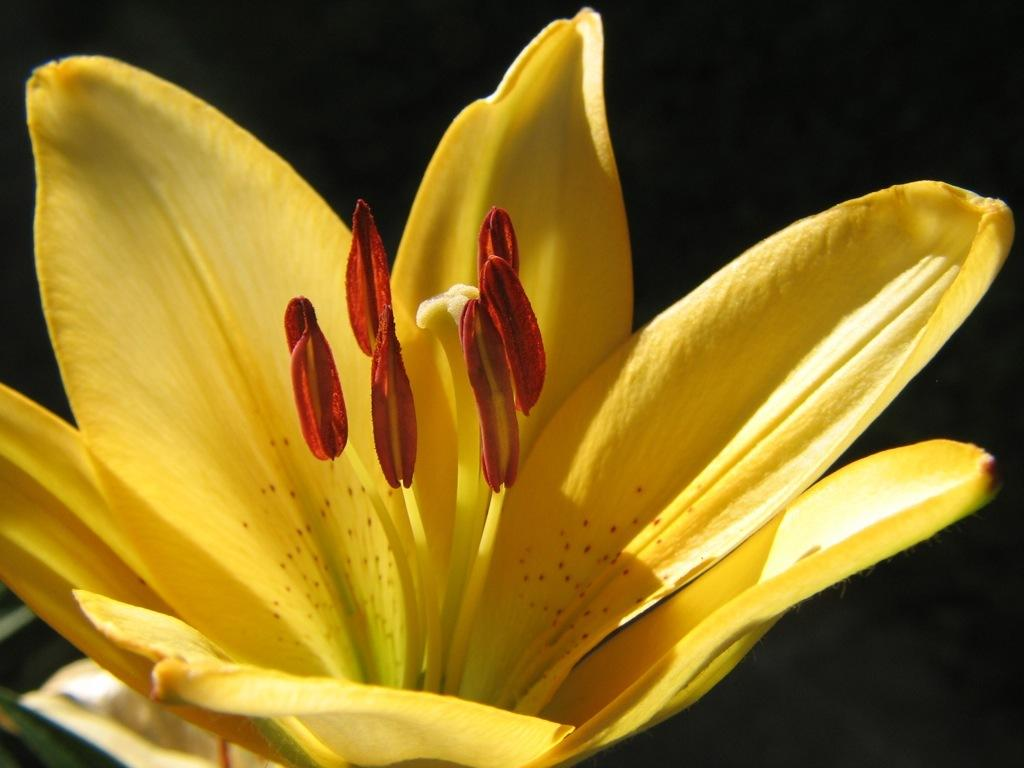What type of flower is present in the image? There is a yellow color flower in the image. What can be observed about the background of the image? The image has a dark background. How many ants can be seen crawling on the lunchroom table in the image? There are no ants or lunchroom table present in the image; it features a yellow color flower with a dark background. 